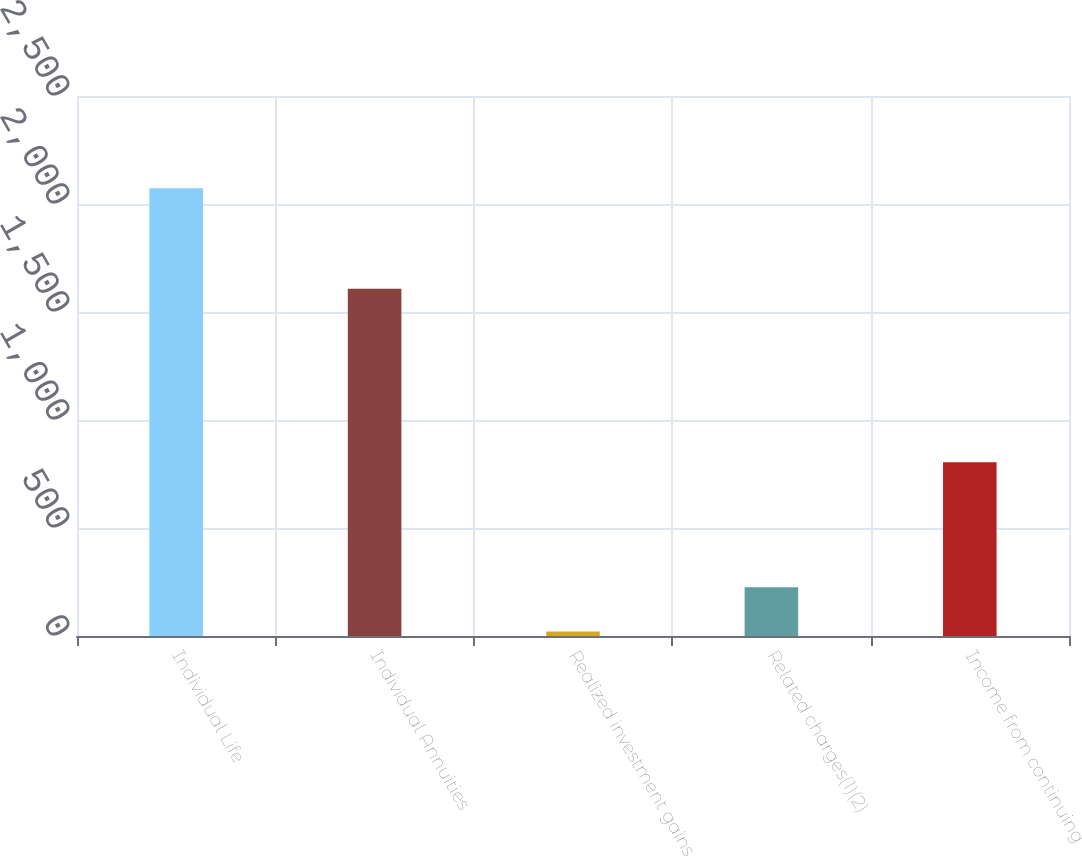<chart> <loc_0><loc_0><loc_500><loc_500><bar_chart><fcel>Individual Life<fcel>Individual Annuities<fcel>Realized investment gains<fcel>Related charges(1)(2)<fcel>Income from continuing<nl><fcel>2073<fcel>1608<fcel>21<fcel>226.2<fcel>804<nl></chart> 